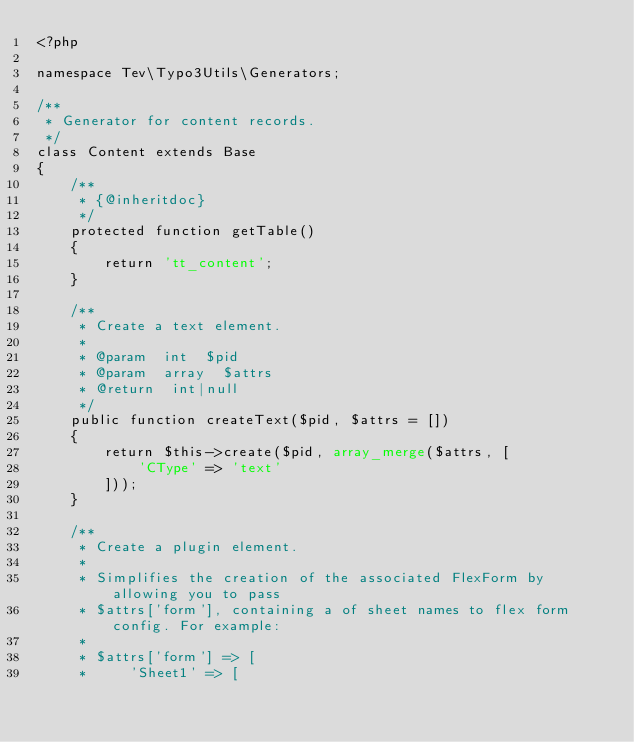Convert code to text. <code><loc_0><loc_0><loc_500><loc_500><_PHP_><?php

namespace Tev\Typo3Utils\Generators;

/**
 * Generator for content records.
 */
class Content extends Base
{
    /**
     * {@inheritdoc}
     */
    protected function getTable()
    {
        return 'tt_content';
    }

    /**
     * Create a text element.
     *
     * @param  int  $pid
     * @param  array  $attrs
     * @return  int|null
     */
    public function createText($pid, $attrs = [])
    {
        return $this->create($pid, array_merge($attrs, [
            'CType' => 'text'
        ]));
    }

    /**
     * Create a plugin element.
     *
     * Simplifies the creation of the associated FlexForm by allowing you to pass
     * $attrs['form'], containing a of sheet names to flex form config. For example:
     *
     * $attrs['form'] => [
     *     'Sheet1' => [</code> 